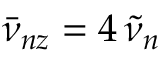<formula> <loc_0><loc_0><loc_500><loc_500>\bar { \nu } _ { n z } = 4 \, \tilde { \nu } _ { n }</formula> 